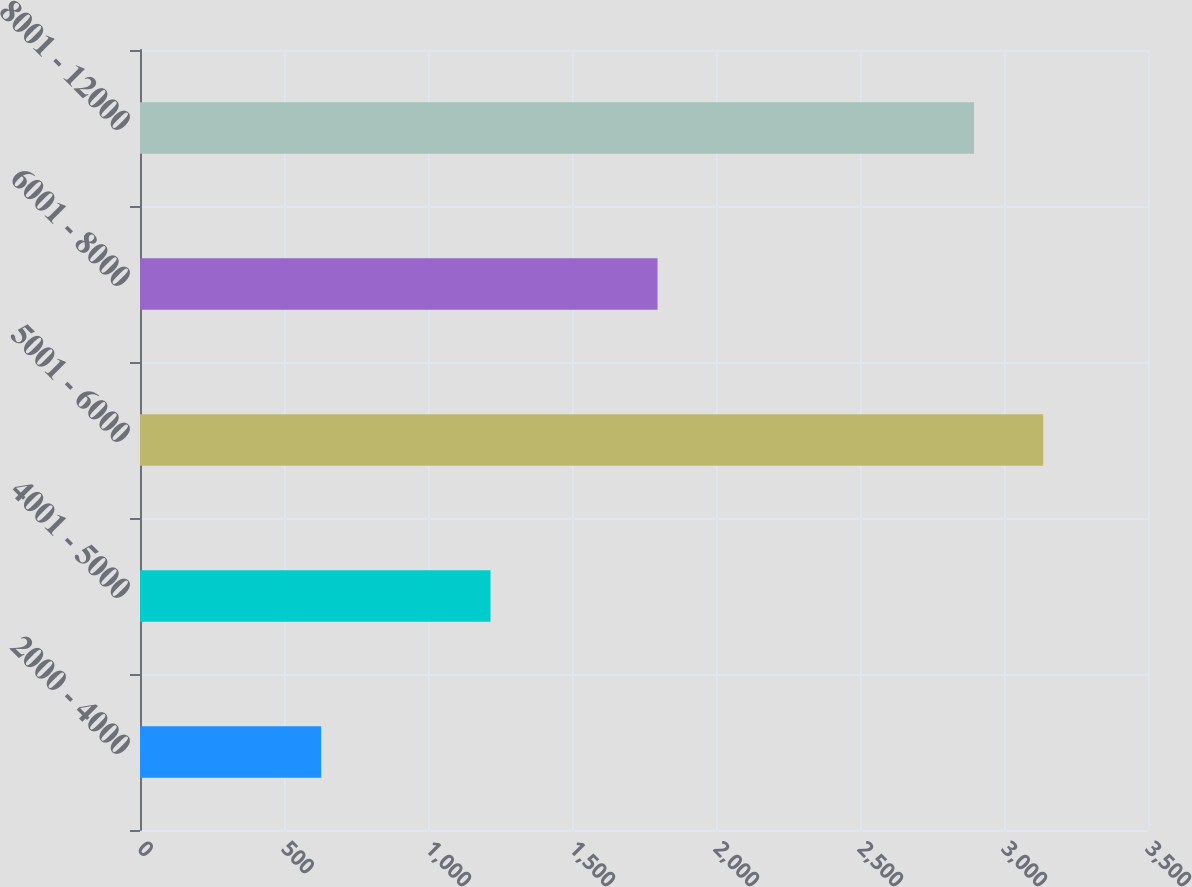<chart> <loc_0><loc_0><loc_500><loc_500><bar_chart><fcel>2000 - 4000<fcel>4001 - 5000<fcel>5001 - 6000<fcel>6001 - 8000<fcel>8001 - 12000<nl><fcel>629<fcel>1217<fcel>3136.2<fcel>1797<fcel>2896<nl></chart> 